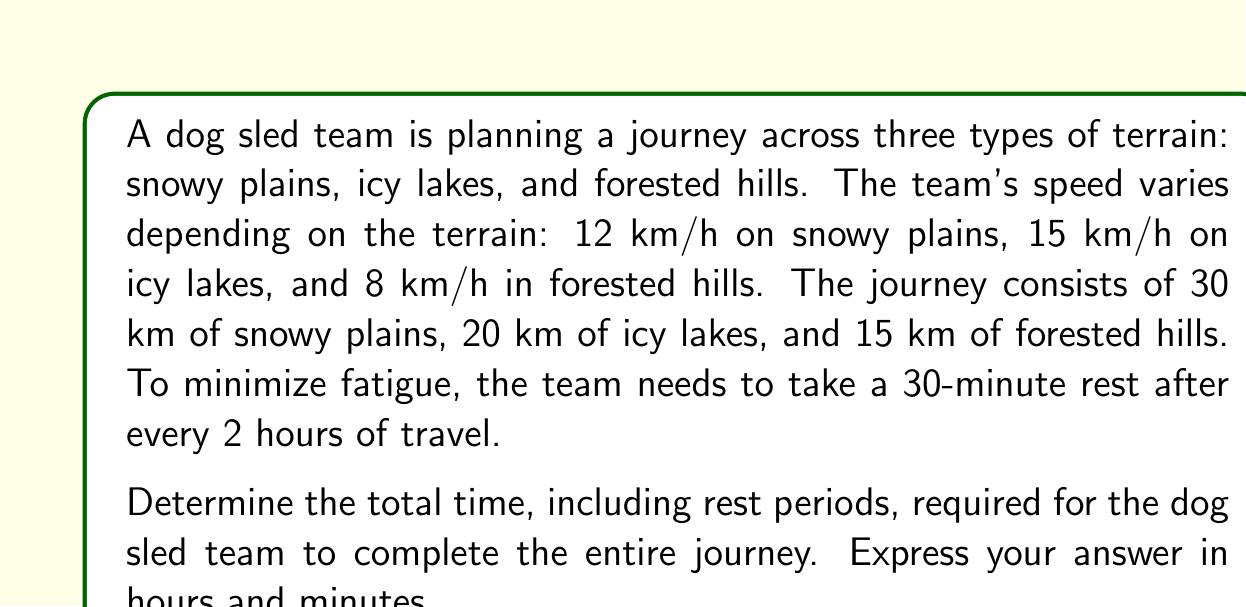Teach me how to tackle this problem. Let's approach this problem step by step:

1) First, let's calculate the time required for each terrain type:

   Snowy plains: $t_1 = \frac{30 \text{ km}}{12 \text{ km/h}} = 2.5 \text{ hours}$
   Icy lakes: $t_2 = \frac{20 \text{ km}}{15 \text{ km/h}} = 1.33 \text{ hours}$
   Forested hills: $t_3 = \frac{15 \text{ km}}{8 \text{ km/h}} = 1.875 \text{ hours}$

2) Total travel time without rest:
   $$t_{\text{total}} = t_1 + t_2 + t_3 = 2.5 + 1.33 + 1.875 = 5.705 \text{ hours}$$

3) Now, we need to calculate the number of rest periods. The team rests every 2 hours, so we divide the total time by 2 and round down:
   $$\text{Number of rest periods} = \left\lfloor\frac{5.705}{2}\right\rfloor = 2$$

4) Each rest period is 30 minutes or 0.5 hours. So the total rest time is:
   $$t_{\text{rest}} = 2 \times 0.5 = 1 \text{ hour}$$

5) The total journey time is the sum of travel time and rest time:
   $$t_{\text{journey}} = t_{\text{total}} + t_{\text{rest}} = 5.705 + 1 = 6.705 \text{ hours}$$

6) To convert 0.705 hours to minutes:
   $$0.705 \times 60 = 42.3 \text{ minutes}$$

Therefore, the total journey time is 6 hours and 42 minutes (rounding to the nearest minute).
Answer: 6 hours and 42 minutes 